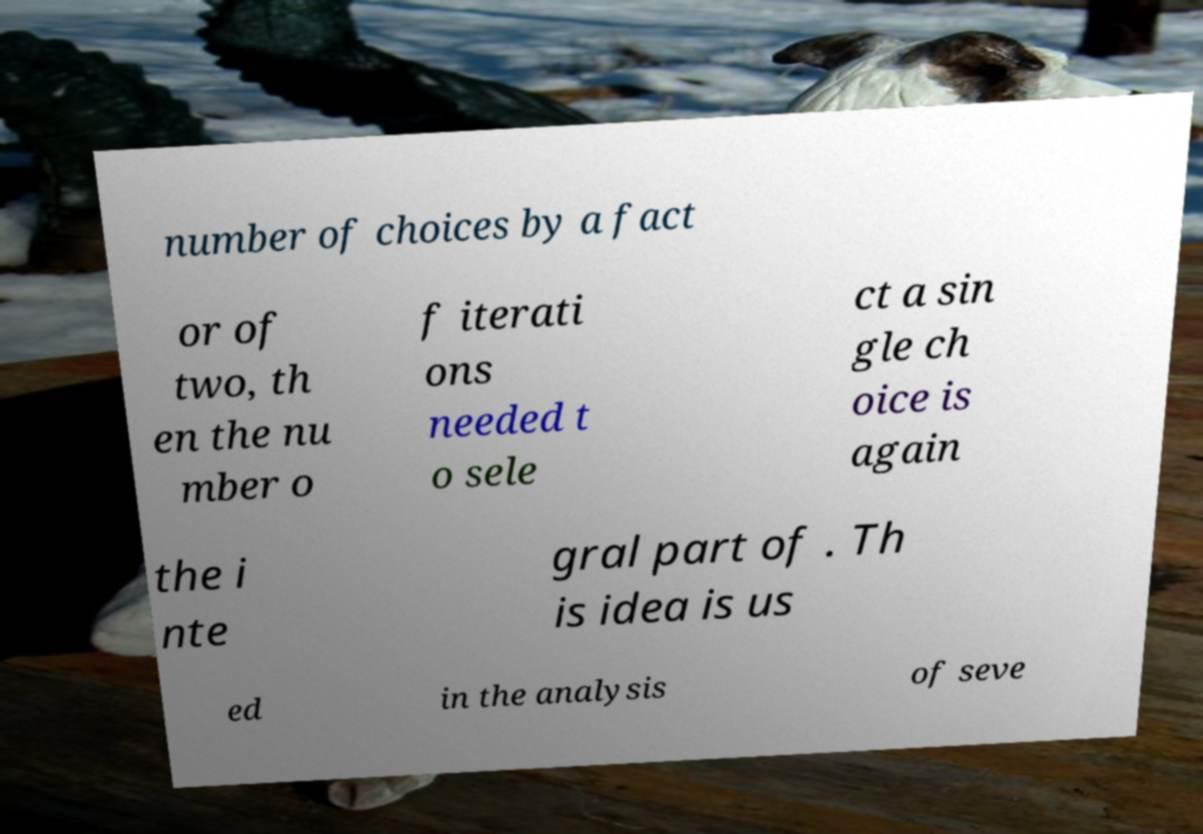For documentation purposes, I need the text within this image transcribed. Could you provide that? number of choices by a fact or of two, th en the nu mber o f iterati ons needed t o sele ct a sin gle ch oice is again the i nte gral part of . Th is idea is us ed in the analysis of seve 